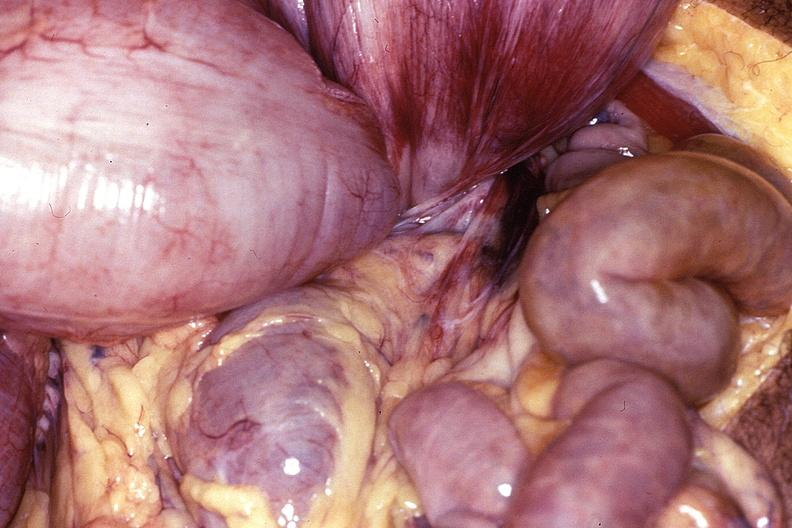what does this image show?
Answer the question using a single word or phrase. Intestine 